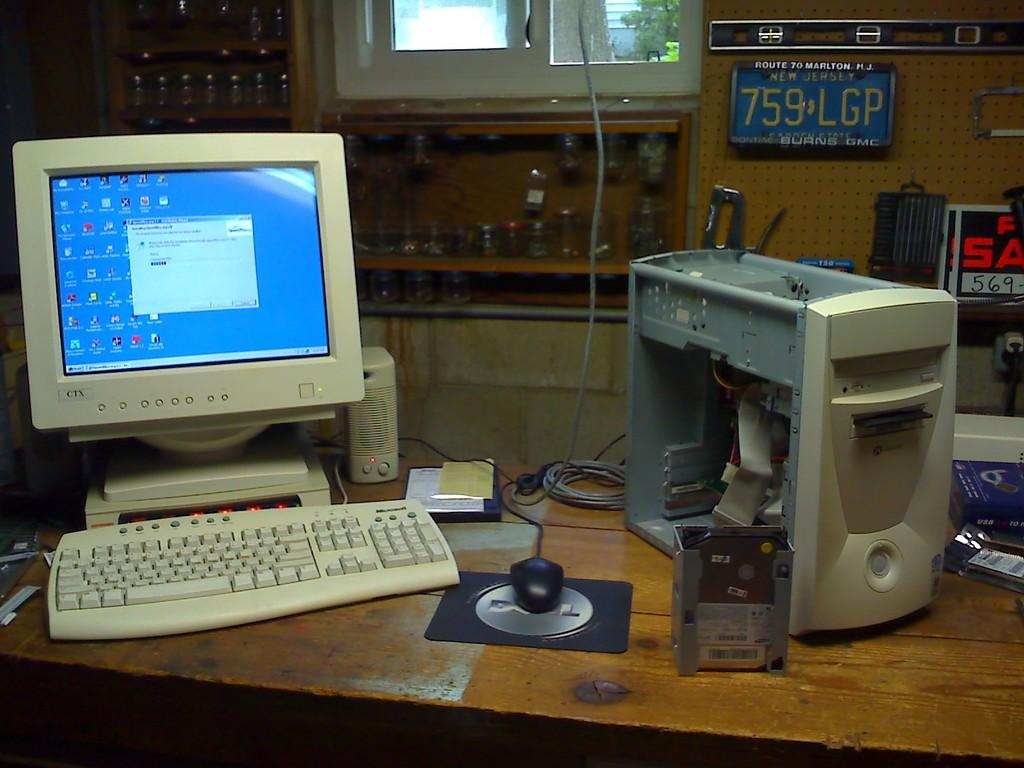<image>
Give a short and clear explanation of the subsequent image. White desktop computer in a room with a blue license plate saying 759LGP. 